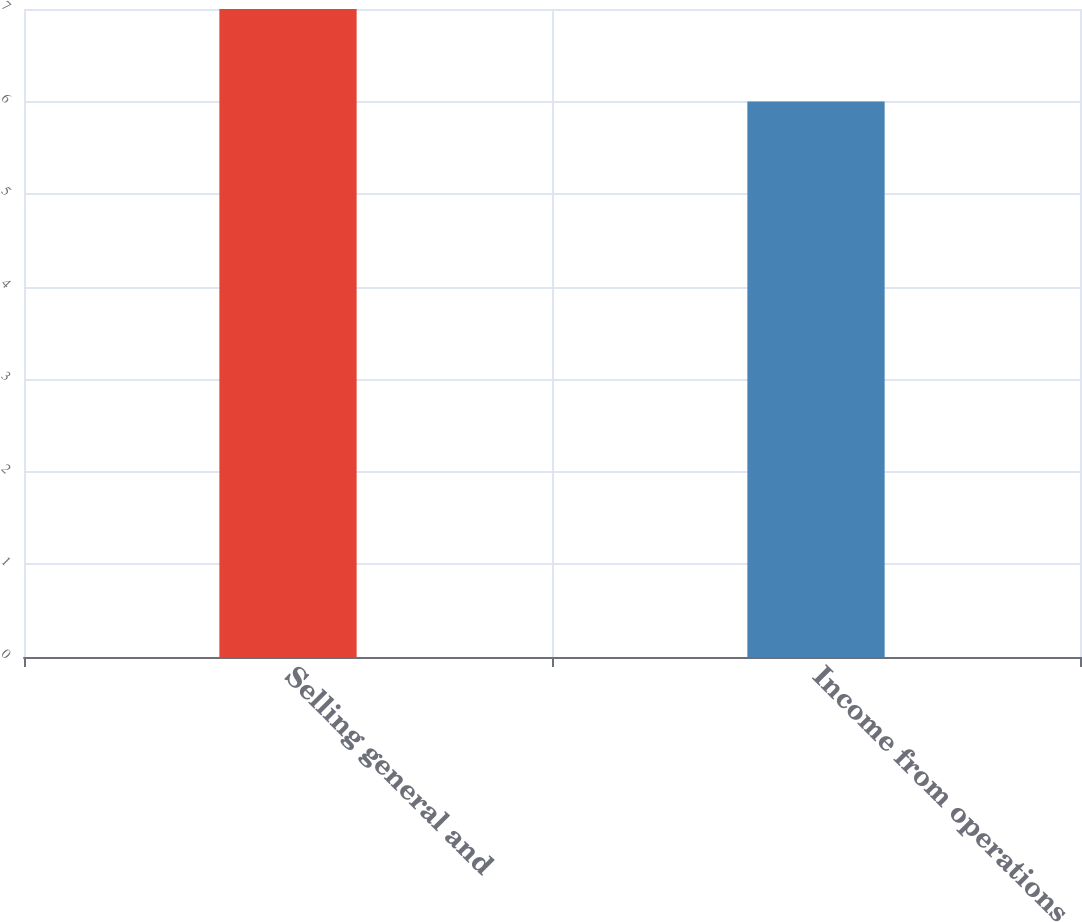Convert chart to OTSL. <chart><loc_0><loc_0><loc_500><loc_500><bar_chart><fcel>Selling general and<fcel>Income from operations<nl><fcel>7<fcel>6<nl></chart> 